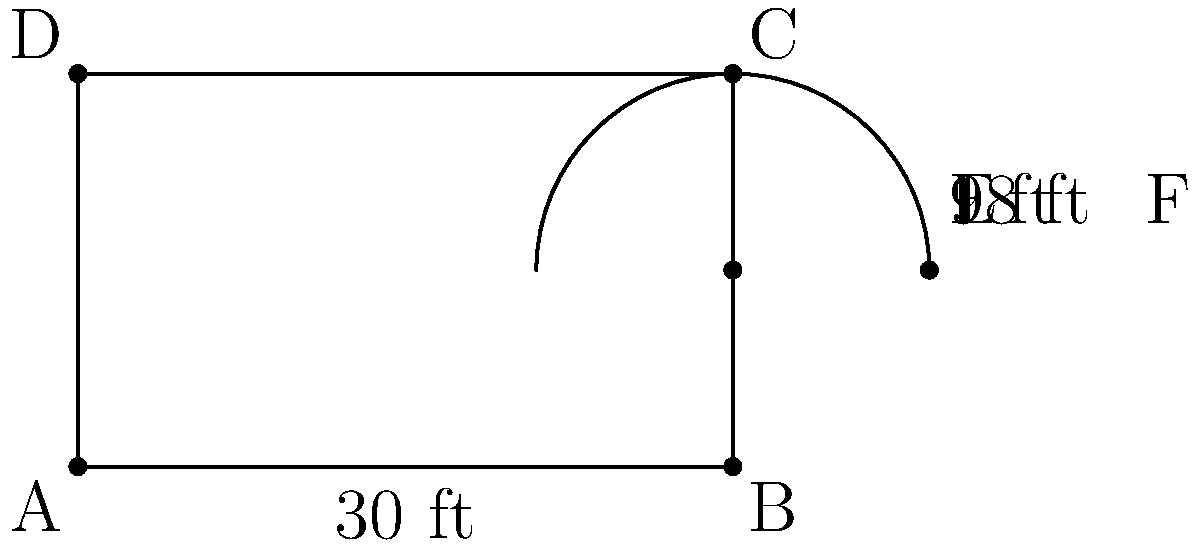The Grace Lutheran School in Huntsville, Alabama is planning to expand its playground. The new design includes a rectangular play area with an attached semicircular sandbox. The rectangular area measures 30 feet by 18 feet, and the radius of the semicircular sandbox is 9 feet. What is the total area of the new playground, including both the rectangular area and the semicircular sandbox? Let's break this problem down into steps:

1. Calculate the area of the rectangular playground:
   Area of rectangle = length × width
   $A_r = 30 \text{ ft} \times 18 \text{ ft} = 540 \text{ sq ft}$

2. Calculate the area of the semicircular sandbox:
   Area of semicircle = $\frac{1}{2} \times \pi r^2$
   $A_s = \frac{1}{2} \times \pi \times (9 \text{ ft})^2$
   $A_s = \frac{1}{2} \times \pi \times 81 \text{ sq ft}$
   $A_s \approx 127.23 \text{ sq ft}$

3. Add the two areas together to get the total area:
   Total Area = Area of rectangle + Area of semicircle
   $A_t = 540 \text{ sq ft} + 127.23 \text{ sq ft}$
   $A_t \approx 667.23 \text{ sq ft}$

Therefore, the total area of the new playground is approximately 667.23 square feet.
Answer: $667.23 \text{ sq ft}$ 